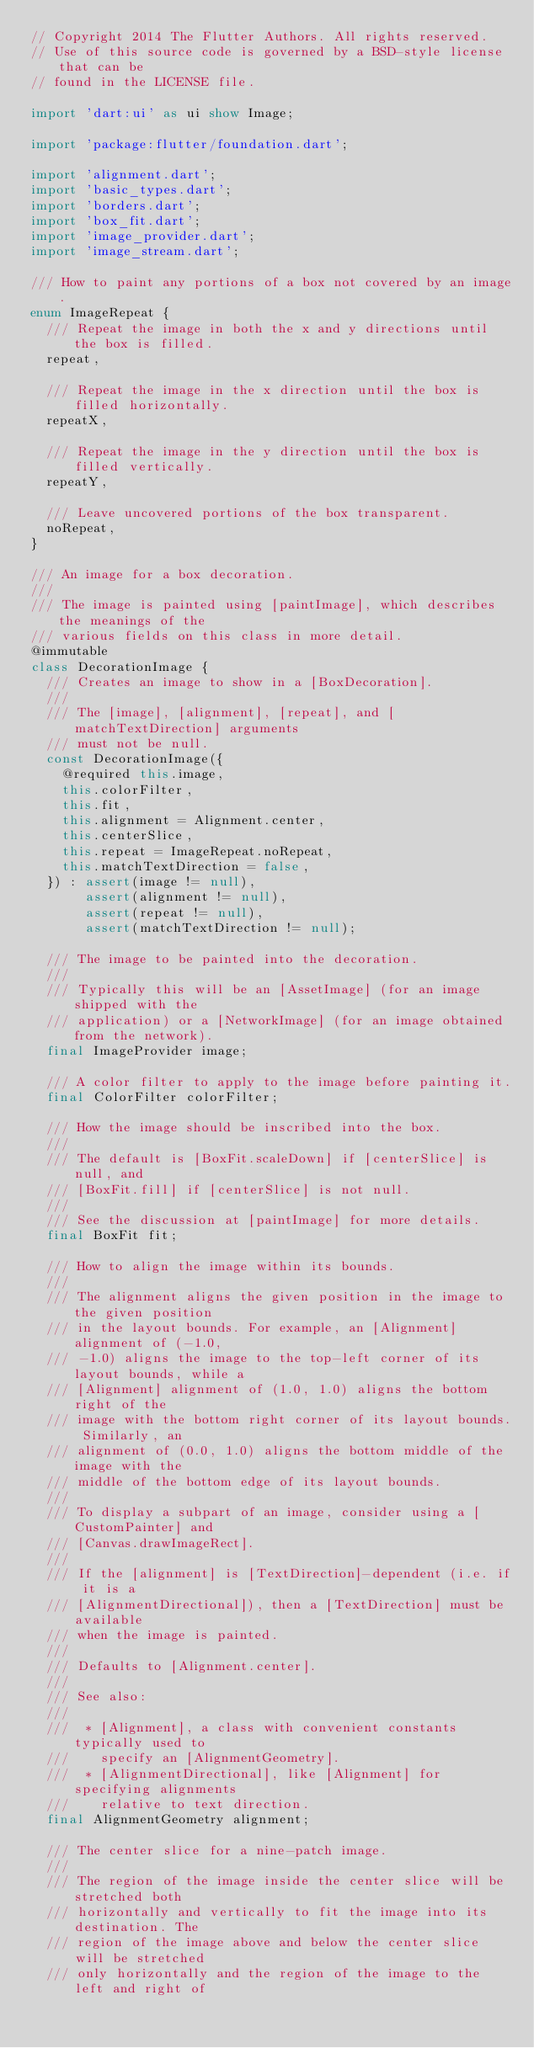<code> <loc_0><loc_0><loc_500><loc_500><_Dart_>// Copyright 2014 The Flutter Authors. All rights reserved.
// Use of this source code is governed by a BSD-style license that can be
// found in the LICENSE file.

import 'dart:ui' as ui show Image;

import 'package:flutter/foundation.dart';

import 'alignment.dart';
import 'basic_types.dart';
import 'borders.dart';
import 'box_fit.dart';
import 'image_provider.dart';
import 'image_stream.dart';

/// How to paint any portions of a box not covered by an image.
enum ImageRepeat {
  /// Repeat the image in both the x and y directions until the box is filled.
  repeat,

  /// Repeat the image in the x direction until the box is filled horizontally.
  repeatX,

  /// Repeat the image in the y direction until the box is filled vertically.
  repeatY,

  /// Leave uncovered portions of the box transparent.
  noRepeat,
}

/// An image for a box decoration.
///
/// The image is painted using [paintImage], which describes the meanings of the
/// various fields on this class in more detail.
@immutable
class DecorationImage {
  /// Creates an image to show in a [BoxDecoration].
  ///
  /// The [image], [alignment], [repeat], and [matchTextDirection] arguments
  /// must not be null.
  const DecorationImage({
    @required this.image,
    this.colorFilter,
    this.fit,
    this.alignment = Alignment.center,
    this.centerSlice,
    this.repeat = ImageRepeat.noRepeat,
    this.matchTextDirection = false,
  }) : assert(image != null),
       assert(alignment != null),
       assert(repeat != null),
       assert(matchTextDirection != null);

  /// The image to be painted into the decoration.
  ///
  /// Typically this will be an [AssetImage] (for an image shipped with the
  /// application) or a [NetworkImage] (for an image obtained from the network).
  final ImageProvider image;

  /// A color filter to apply to the image before painting it.
  final ColorFilter colorFilter;

  /// How the image should be inscribed into the box.
  ///
  /// The default is [BoxFit.scaleDown] if [centerSlice] is null, and
  /// [BoxFit.fill] if [centerSlice] is not null.
  ///
  /// See the discussion at [paintImage] for more details.
  final BoxFit fit;

  /// How to align the image within its bounds.
  ///
  /// The alignment aligns the given position in the image to the given position
  /// in the layout bounds. For example, an [Alignment] alignment of (-1.0,
  /// -1.0) aligns the image to the top-left corner of its layout bounds, while a
  /// [Alignment] alignment of (1.0, 1.0) aligns the bottom right of the
  /// image with the bottom right corner of its layout bounds. Similarly, an
  /// alignment of (0.0, 1.0) aligns the bottom middle of the image with the
  /// middle of the bottom edge of its layout bounds.
  ///
  /// To display a subpart of an image, consider using a [CustomPainter] and
  /// [Canvas.drawImageRect].
  ///
  /// If the [alignment] is [TextDirection]-dependent (i.e. if it is a
  /// [AlignmentDirectional]), then a [TextDirection] must be available
  /// when the image is painted.
  ///
  /// Defaults to [Alignment.center].
  ///
  /// See also:
  ///
  ///  * [Alignment], a class with convenient constants typically used to
  ///    specify an [AlignmentGeometry].
  ///  * [AlignmentDirectional], like [Alignment] for specifying alignments
  ///    relative to text direction.
  final AlignmentGeometry alignment;

  /// The center slice for a nine-patch image.
  ///
  /// The region of the image inside the center slice will be stretched both
  /// horizontally and vertically to fit the image into its destination. The
  /// region of the image above and below the center slice will be stretched
  /// only horizontally and the region of the image to the left and right of</code> 